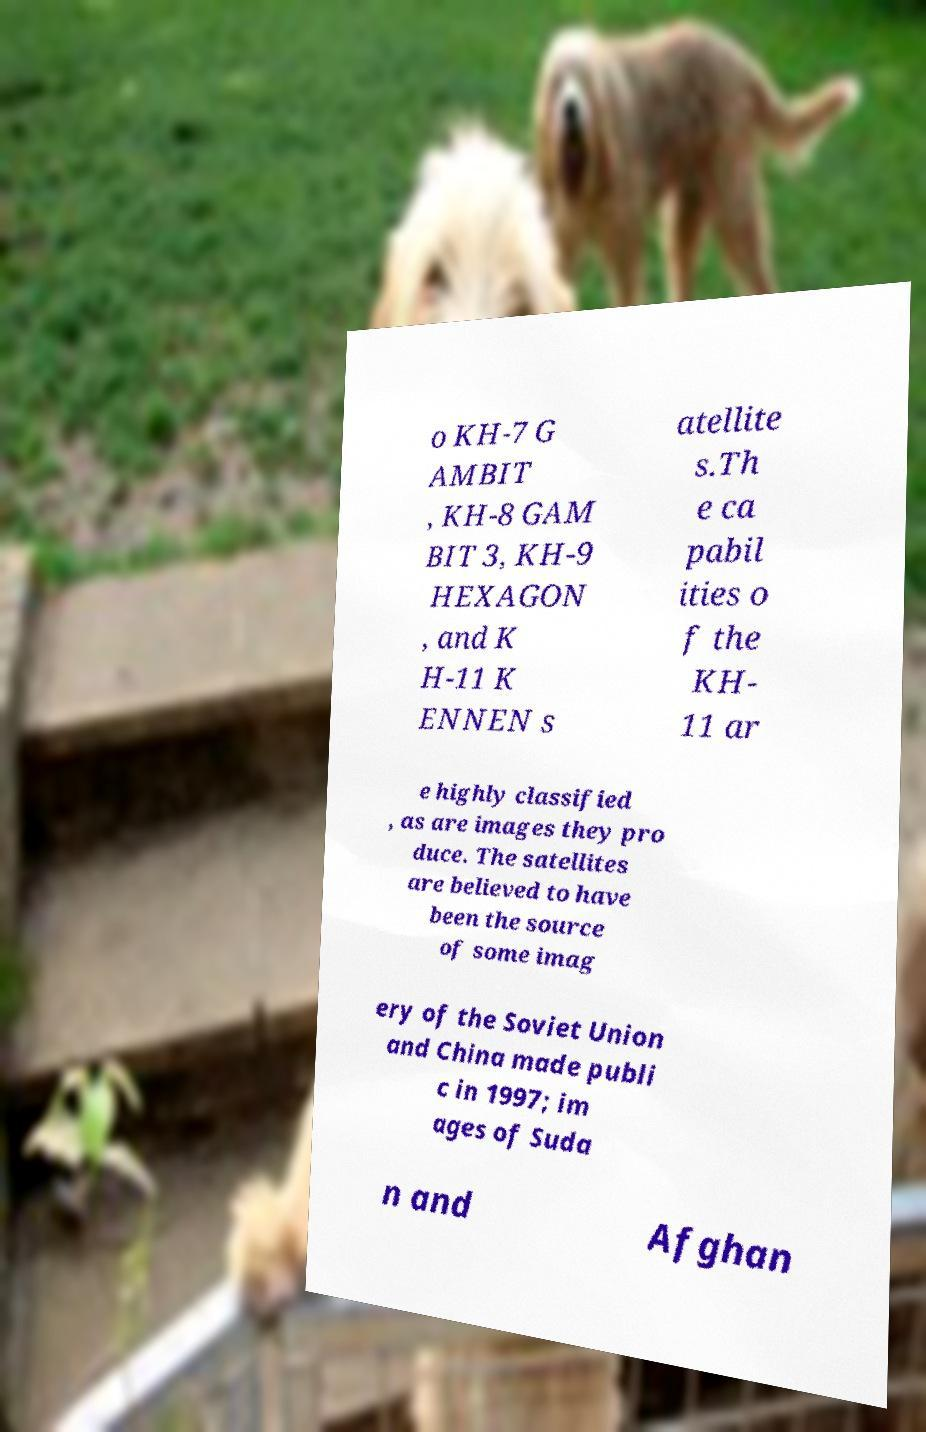For documentation purposes, I need the text within this image transcribed. Could you provide that? o KH-7 G AMBIT , KH-8 GAM BIT 3, KH-9 HEXAGON , and K H-11 K ENNEN s atellite s.Th e ca pabil ities o f the KH- 11 ar e highly classified , as are images they pro duce. The satellites are believed to have been the source of some imag ery of the Soviet Union and China made publi c in 1997; im ages of Suda n and Afghan 